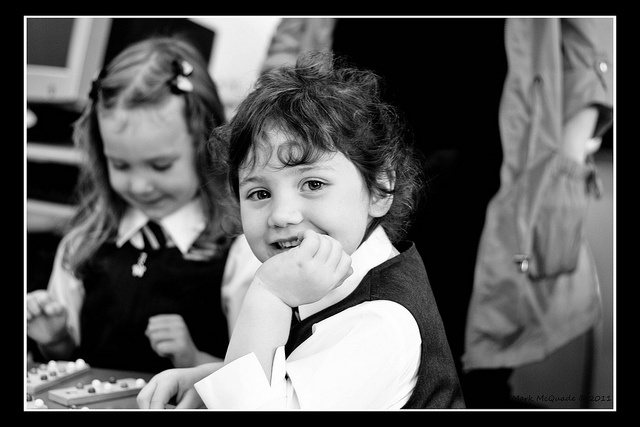Describe the objects in this image and their specific colors. I can see people in black, gray, and lightgray tones, people in black, white, gray, and darkgray tones, people in black, darkgray, gray, and lightgray tones, and tie in gray, black, and darkgray tones in this image. 